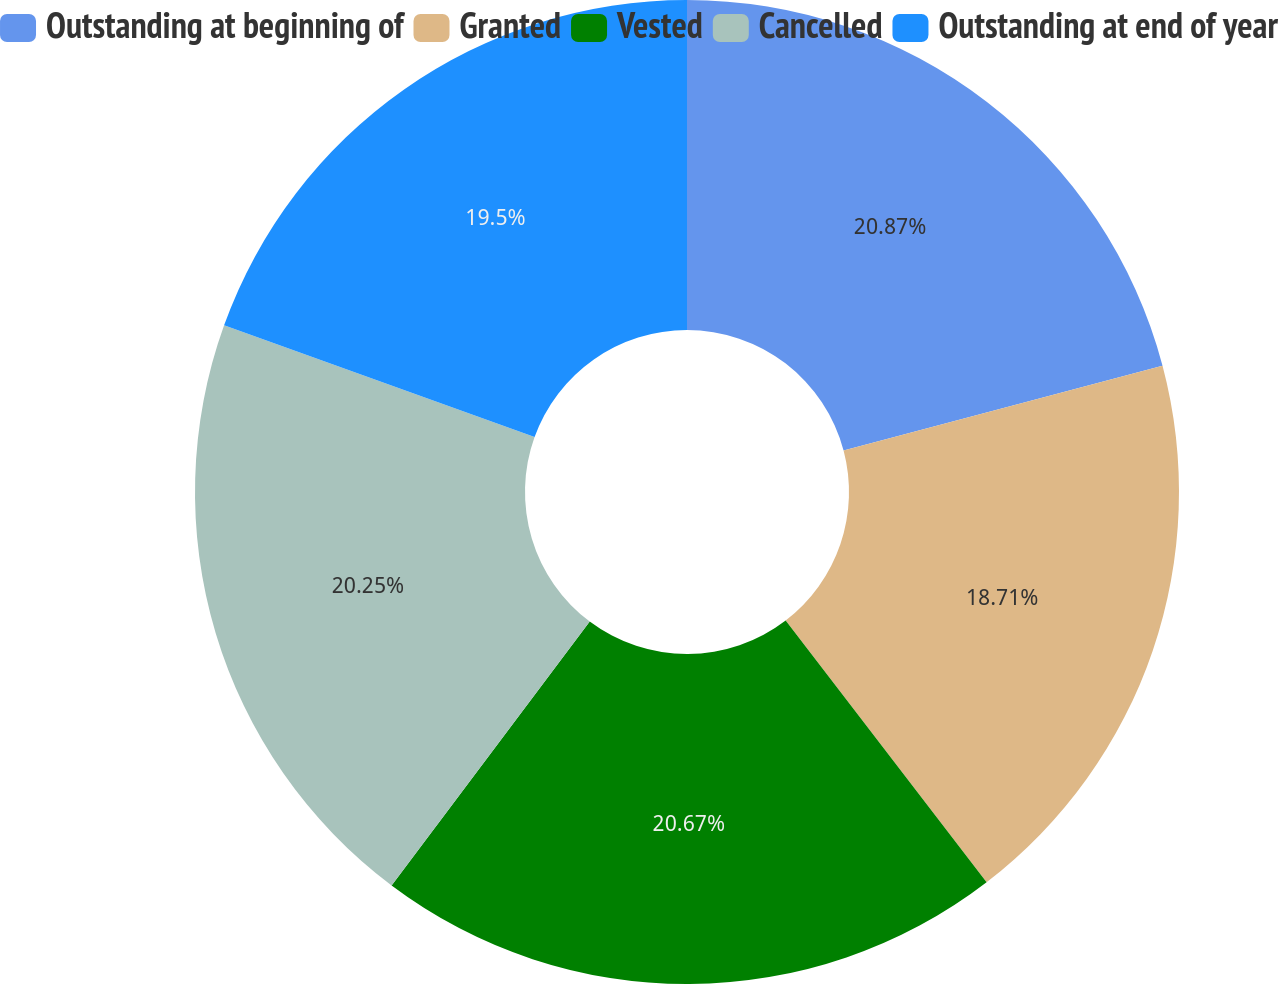Convert chart. <chart><loc_0><loc_0><loc_500><loc_500><pie_chart><fcel>Outstanding at beginning of<fcel>Granted<fcel>Vested<fcel>Cancelled<fcel>Outstanding at end of year<nl><fcel>20.87%<fcel>18.71%<fcel>20.67%<fcel>20.25%<fcel>19.5%<nl></chart> 